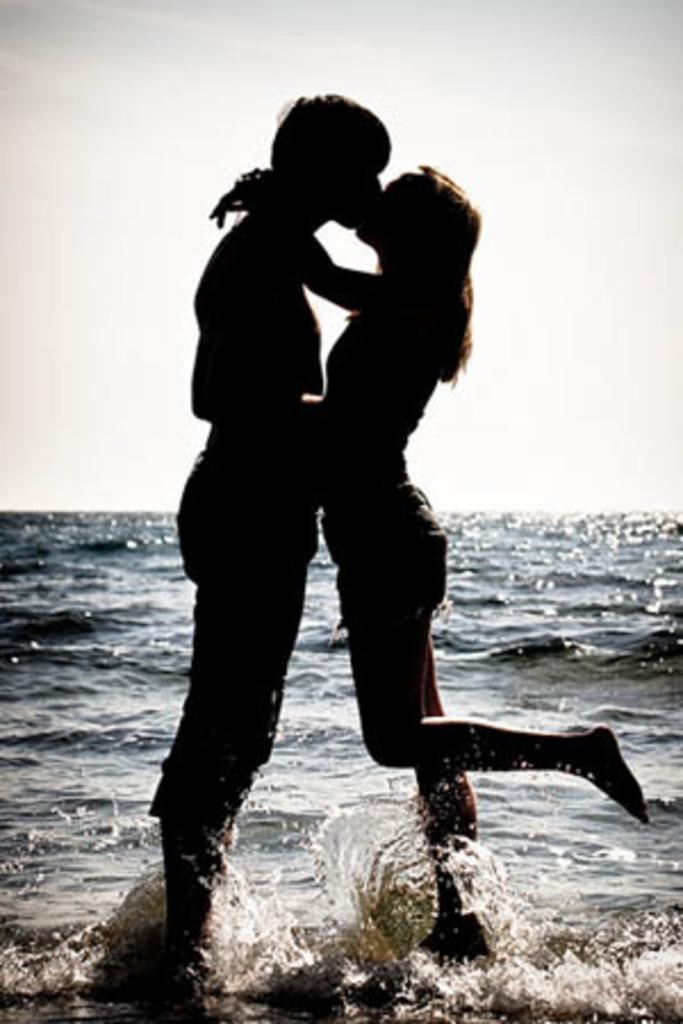Where was the image taken? The image is clicked outside. How many people are in the foreground of the image? There are two people standing in the foreground. What are the two people doing in the image? The two people appear to be kissing each other. What can be seen in the background of the image? There is a sky and a water body visible in the background. What type of scarf is being used by the person in the image? There is no scarf visible in the image. What scene is being depicted in the image? The image is not a scene; it is a photograph of two people kissing each other outside. 